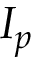Convert formula to latex. <formula><loc_0><loc_0><loc_500><loc_500>I _ { p }</formula> 